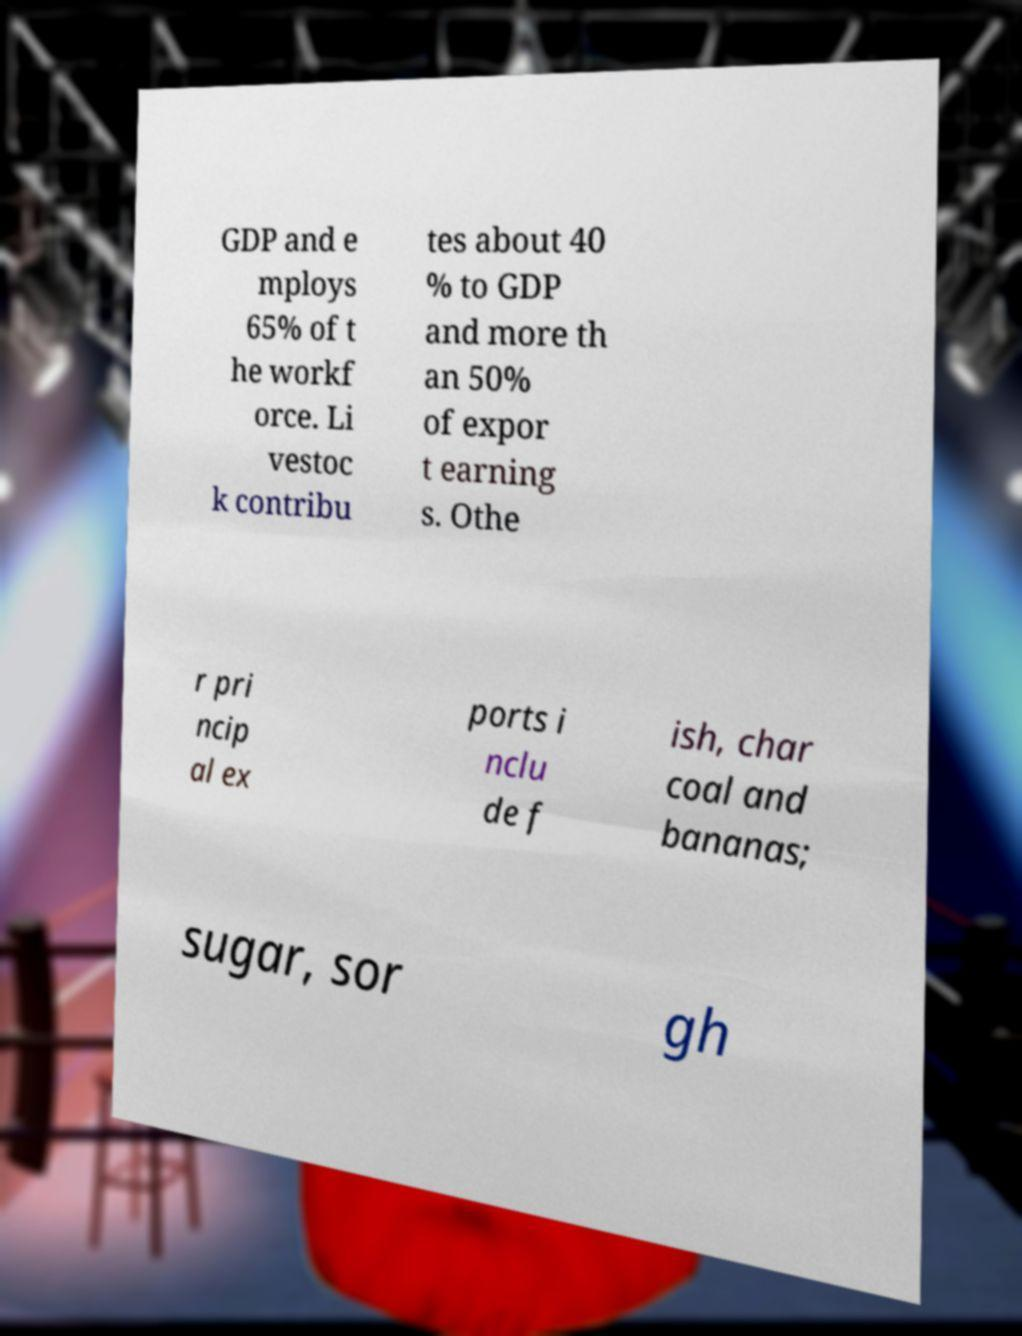Please read and relay the text visible in this image. What does it say? GDP and e mploys 65% of t he workf orce. Li vestoc k contribu tes about 40 % to GDP and more th an 50% of expor t earning s. Othe r pri ncip al ex ports i nclu de f ish, char coal and bananas; sugar, sor gh 